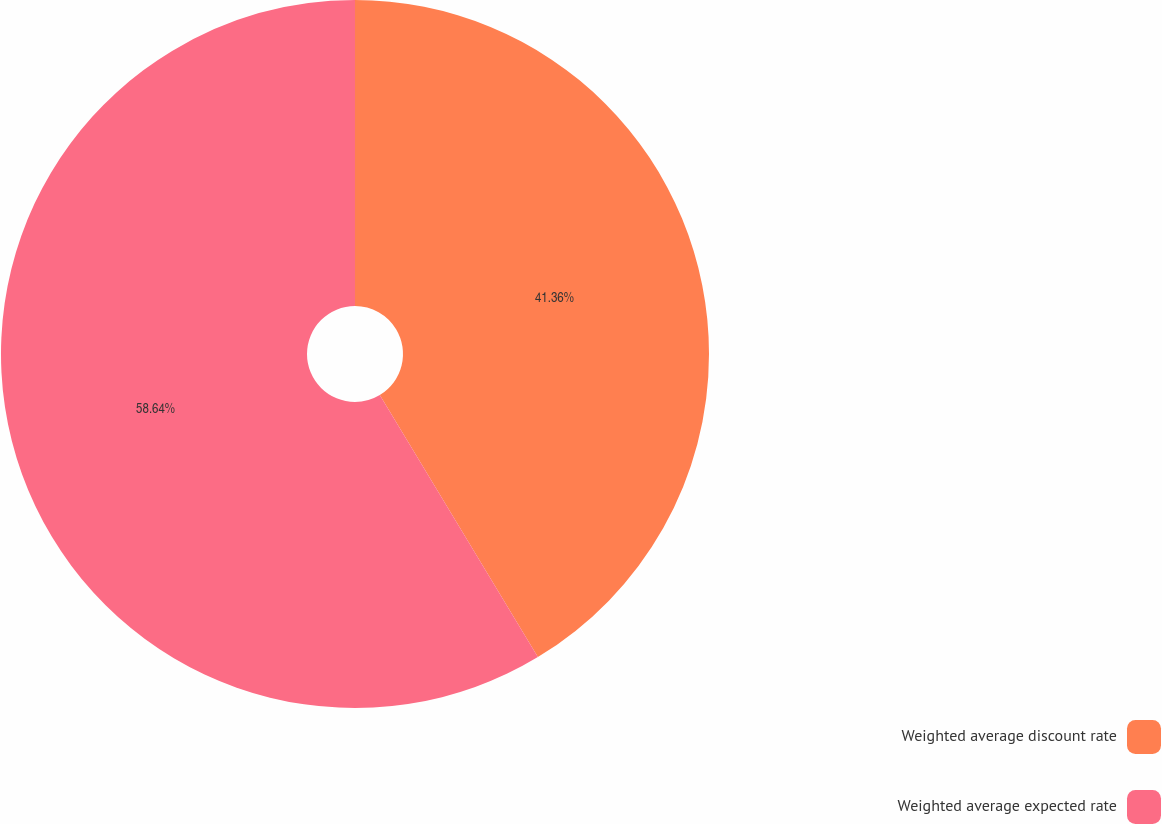Convert chart. <chart><loc_0><loc_0><loc_500><loc_500><pie_chart><fcel>Weighted average discount rate<fcel>Weighted average expected rate<nl><fcel>41.36%<fcel>58.64%<nl></chart> 